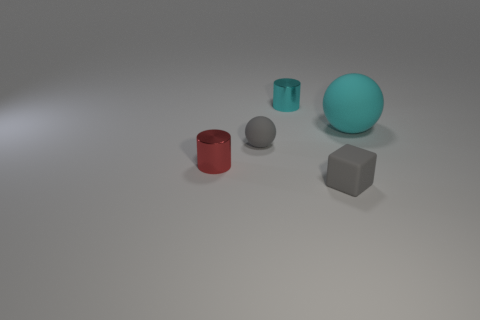Is there any other thing that has the same material as the red object?
Make the answer very short. Yes. There is a gray rubber thing on the right side of the cyan metal thing; are there any small blocks that are right of it?
Your answer should be compact. No. What color is the cylinder in front of the cyan metallic thing?
Provide a short and direct response. Red. Are there an equal number of cyan cylinders that are to the right of the big thing and tiny cyan cylinders?
Your answer should be very brief. No. What shape is the thing that is in front of the small cyan shiny thing and behind the small rubber ball?
Give a very brief answer. Sphere. There is another tiny thing that is the same shape as the tiny red thing; what is its color?
Make the answer very short. Cyan. Are there any other things that have the same color as the tiny rubber block?
Offer a terse response. Yes. What shape is the small red object that is in front of the rubber ball left of the small object to the right of the tiny cyan cylinder?
Provide a short and direct response. Cylinder. Does the gray object that is behind the small red cylinder have the same size as the gray object that is to the right of the small cyan object?
Keep it short and to the point. Yes. What number of other small gray balls are the same material as the tiny gray ball?
Ensure brevity in your answer.  0. 